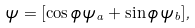Convert formula to latex. <formula><loc_0><loc_0><loc_500><loc_500>\psi = [ \cos \phi \, \psi _ { a } + \sin \phi \, \psi _ { b } ] ,</formula> 